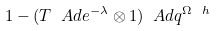Convert formula to latex. <formula><loc_0><loc_0><loc_500><loc_500>1 - ( T \ A d e ^ { - \lambda } \otimes 1 ) \ A d q ^ { \Omega _ { \ } h }</formula> 